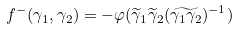<formula> <loc_0><loc_0><loc_500><loc_500>f ^ { - } ( \gamma _ { 1 } , \gamma _ { 2 } ) = - \varphi ( \widetilde { \gamma } _ { 1 } \widetilde { \gamma } _ { 2 } ( \widetilde { \gamma _ { 1 } \gamma _ { 2 } } ) ^ { - 1 } )</formula> 